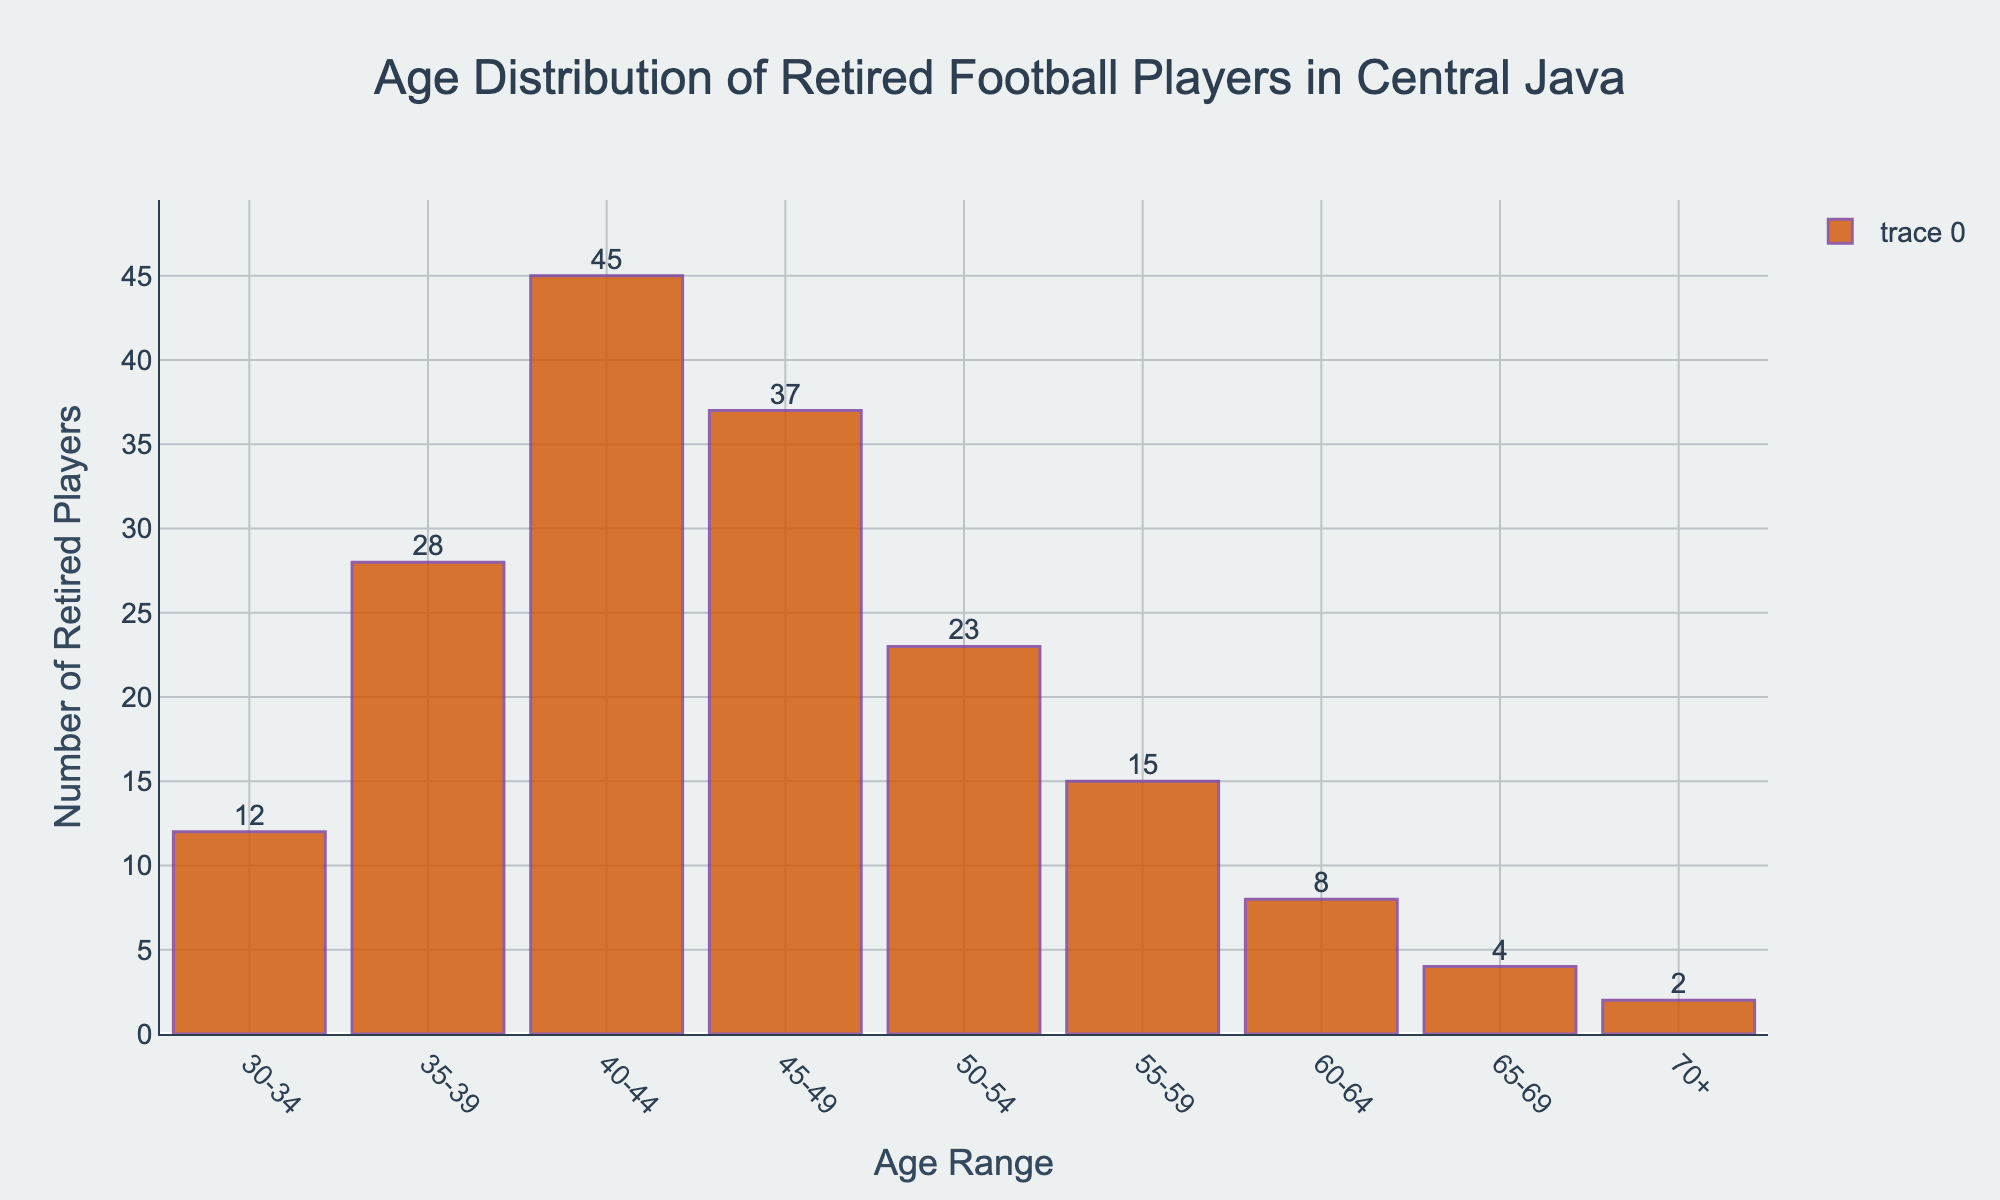What's the most common age range for retired football players in Central Java? Identify the tallest bar in the bar chart, which represents the age range with the highest number of retired football players. The tallest bar is the 40-44 age range.
Answer: 40-44 Which age range has a similar number of retired players as the 50-54 age range? Compare the heights of the bars and their labels. The 45-49 age range has a similar number of retired players (37) to the 50-54 age range (23).
Answer: 45-49 How many more retired players are in the 45-49 age range compared to the 30-34 age range? Subtract the number of players in the 30-34 age range (12) from the number of players in the 45-49 age range (37). 37 - 12 = 25.
Answer: 25 What's the combined total of retired players in the 35-39 and 50-54 age ranges? Sum the number of players in the 35-39 age range (28) and the 50-54 age range (23). 28 + 23 = 51.
Answer: 51 Which age range has the least number of retired football players? Observe the shortest bar in the bar chart, which represents the age range with the lowest number of retired players. The shortest bar is the 70+ range.
Answer: 70+ How many age ranges have more than 20 retired football players each? Count the age ranges where the bar height is greater than the level representing 20 players. The age ranges are 35-39, 40-44, 45-49, and 50-54, making a total of 4.
Answer: 4 Which age range has half the number of retired players compared to the 40-44 age range? Calculate half the number of retired players in the 40-44 age range (45/2 = 22.5). The age range 50-54 has 23 players, which is approximately half.
Answer: 50-54 What is the total number of retired players in the age ranges 55-59 and 70+? Sum the number of players in the 55-59 age range (15) and the 70+ age range (2). 15 + 2 = 17.
Answer: 17 How does the number of retired players in the age range 60-64 compare to the 30-34 age range? Compare the heights of the bars. The 60-64 age range has 8 players while the 30-34 age range has 12 players, so there are 4 fewer in the 60-64 age range.
Answer: 4 fewer 